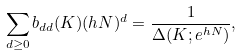<formula> <loc_0><loc_0><loc_500><loc_500>\sum _ { d \geq 0 } b _ { d d } ( K ) ( h N ) ^ { d } = \frac { 1 } { \Delta ( K ; e ^ { h N } ) } ,</formula> 